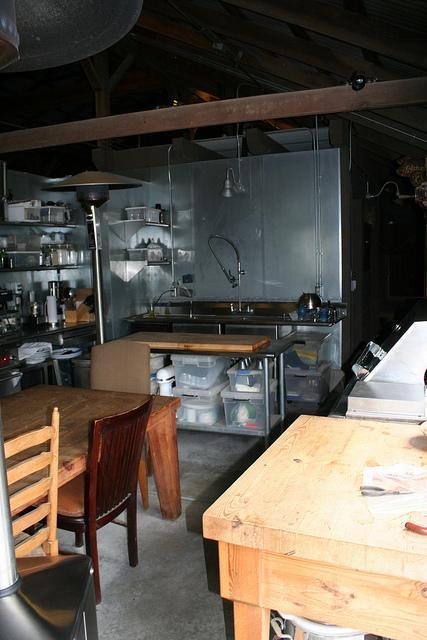How many chairs are in the image?
Give a very brief answer. 2. How many chairs are there?
Give a very brief answer. 3. How many dining tables are there?
Give a very brief answer. 2. How many people are hitting a tennis ball?
Give a very brief answer. 0. 